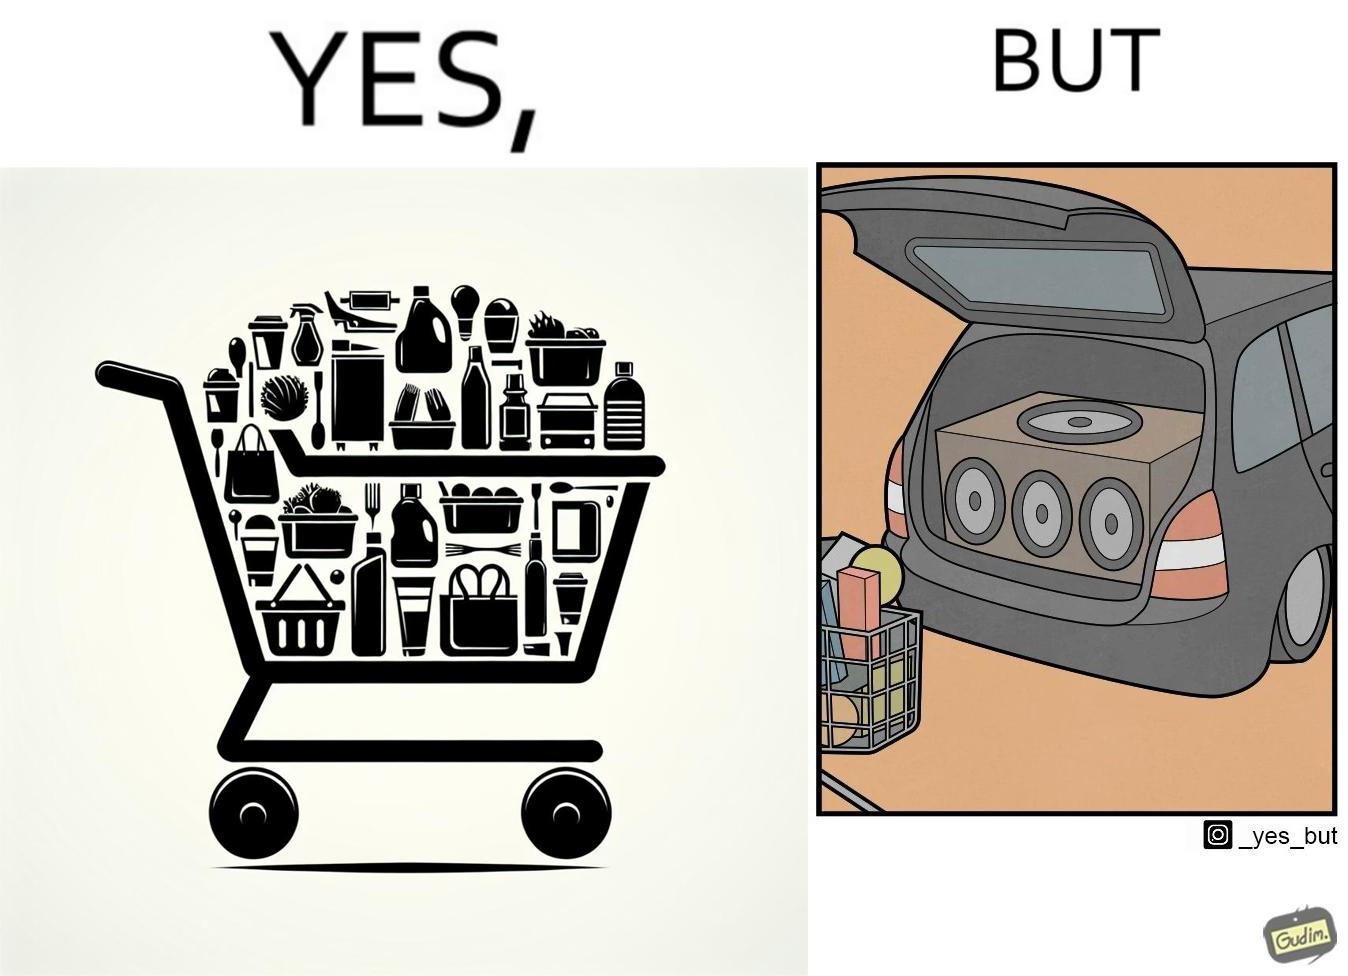Describe the satirical element in this image. The image is ironic, because a car trunk was earlier designed to keep some extra luggage or things but people nowadays get speakers installed in the trunk which in turn reduces the space in the trunk and making it difficult for people to store the extra luggage in the trunk 